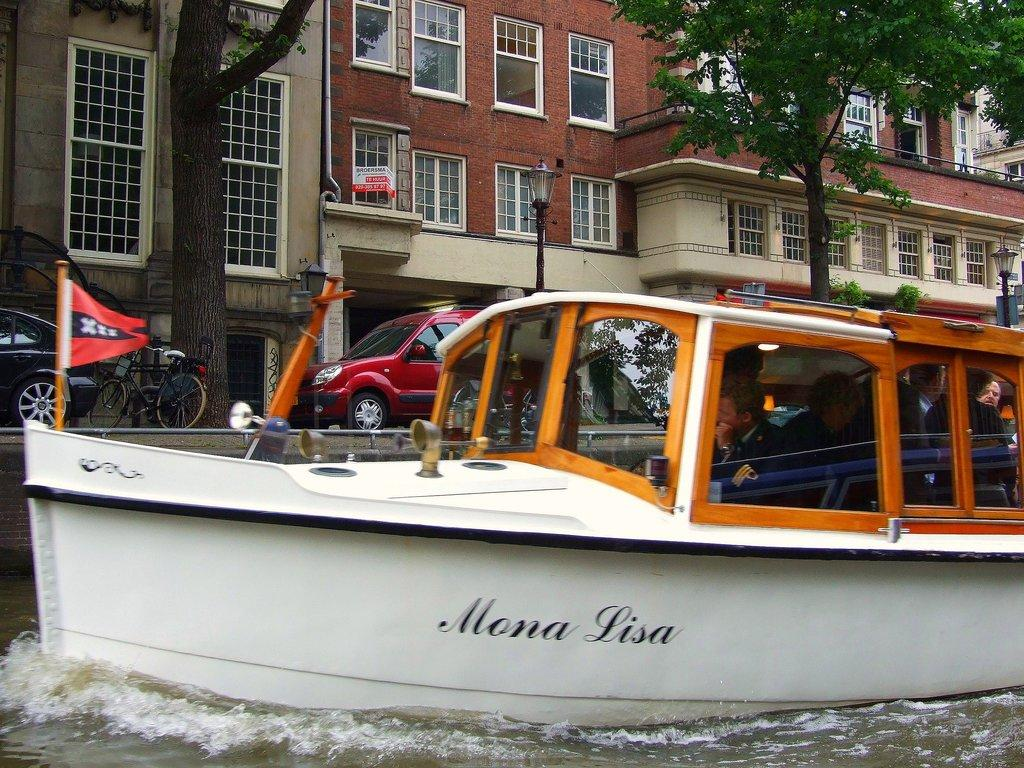What is floating in the water in the image? There is a boat floating in the water in the image. What can be seen in the background of the image? There is a building in the background of the image. What type of vegetation is present in front of the building? Trees are present in front of the building. What else can be seen near the building? There are vehicles parked in front of the building. What type of vase can be seen on the boat in the image? There is no vase present on the boat in the image. What color is the paint on the drawer in the image? There is no drawer present in the image. 